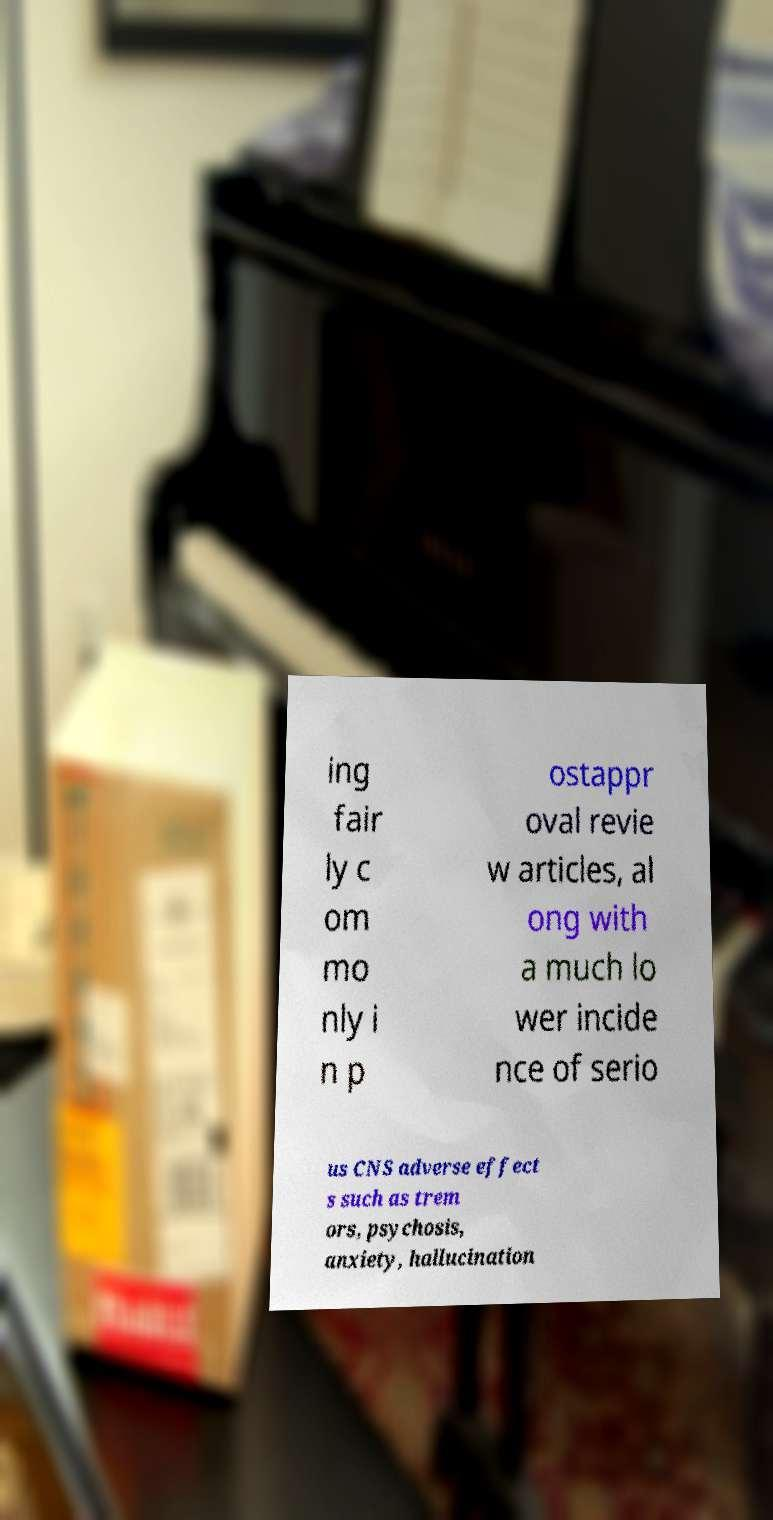What messages or text are displayed in this image? I need them in a readable, typed format. ing fair ly c om mo nly i n p ostappr oval revie w articles, al ong with a much lo wer incide nce of serio us CNS adverse effect s such as trem ors, psychosis, anxiety, hallucination 